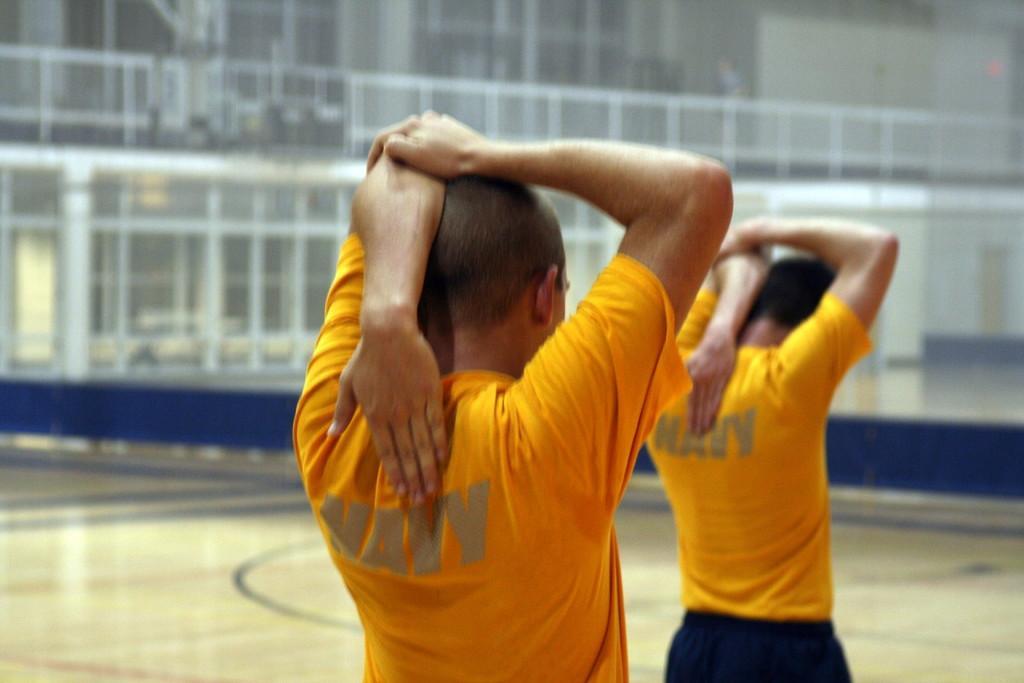How would you summarize this image in a sentence or two? In the center of the image there are two persons wearing yellow color t-shirt. In the background of the image there are rods. At the bottom of the image there is floor. 